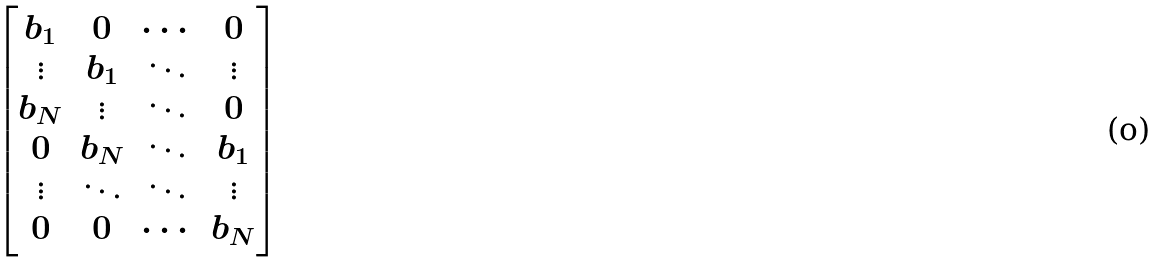Convert formula to latex. <formula><loc_0><loc_0><loc_500><loc_500>\begin{bmatrix} b _ { 1 } & 0 & \cdots & 0 \\ \vdots & b _ { 1 } & \ddots & \vdots \\ b _ { N } & \vdots & \ddots & 0 \\ 0 & b _ { N } & \ddots & b _ { 1 } \\ \vdots & \ddots & \ddots & \vdots \\ 0 & 0 & \cdots & b _ { N } \end{bmatrix}</formula> 